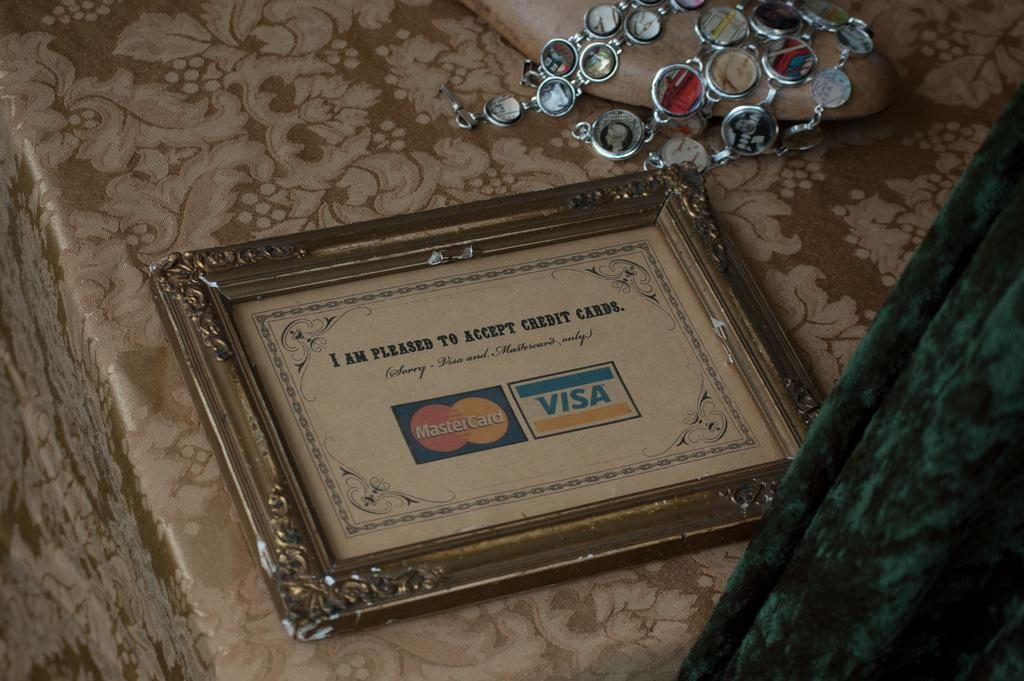What is the main object in the image? There is a frame in the image. What else can be seen in the image? There is an ornament and footwear on a platform in the image. Can you describe the object on the right side of the image? There is a green object on the right side of the image. What type of destruction can be seen in the image? There is no destruction present in the image. Is there a tent visible in the image? There is no tent present in the image. 